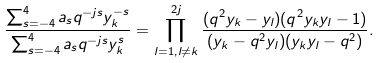Convert formula to latex. <formula><loc_0><loc_0><loc_500><loc_500>\frac { \sum _ { s = - 4 } ^ { 4 } a _ { s } q ^ { - j s } y _ { k } ^ { - s } } { \sum _ { s = - 4 } ^ { 4 } a _ { s } q ^ { - j s } y _ { k } ^ { s } } = \prod _ { l = 1 , l \ne k } ^ { 2 j } \frac { ( q ^ { 2 } y _ { k } - y _ { l } ) ( q ^ { 2 } y _ { k } y _ { l } - 1 ) } { ( y _ { k } - q ^ { 2 } y _ { l } ) ( y _ { k } y _ { l } - q ^ { 2 } ) } .</formula> 